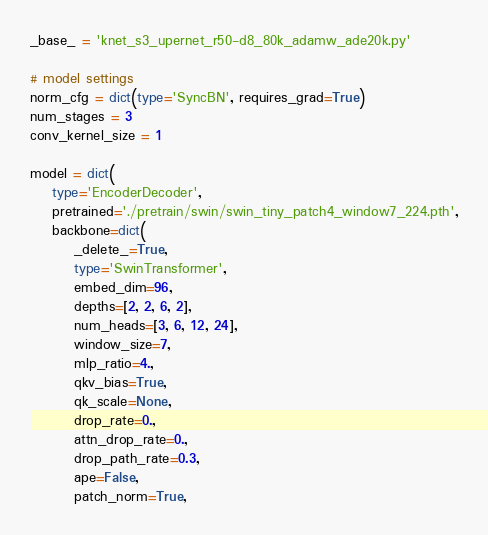<code> <loc_0><loc_0><loc_500><loc_500><_Python_>_base_ = 'knet_s3_upernet_r50-d8_80k_adamw_ade20k.py'

# model settings
norm_cfg = dict(type='SyncBN', requires_grad=True)
num_stages = 3
conv_kernel_size = 1

model = dict(
    type='EncoderDecoder',
    pretrained='./pretrain/swin/swin_tiny_patch4_window7_224.pth',
    backbone=dict(
        _delete_=True,
        type='SwinTransformer',
        embed_dim=96,
        depths=[2, 2, 6, 2],
        num_heads=[3, 6, 12, 24],
        window_size=7,
        mlp_ratio=4.,
        qkv_bias=True,
        qk_scale=None,
        drop_rate=0.,
        attn_drop_rate=0.,
        drop_path_rate=0.3,
        ape=False,
        patch_norm=True,</code> 